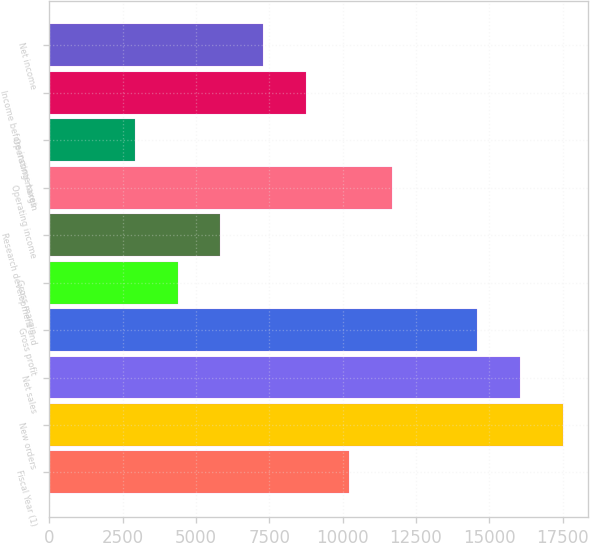Convert chart to OTSL. <chart><loc_0><loc_0><loc_500><loc_500><bar_chart><fcel>Fiscal Year (1)<fcel>New orders<fcel>Net sales<fcel>Gross profit<fcel>Gross margin<fcel>Research development and<fcel>Operating income<fcel>Operating margin<fcel>Income before income taxes<fcel>Net income<nl><fcel>10211.7<fcel>17505.5<fcel>16046.8<fcel>14588<fcel>4376.68<fcel>5835.44<fcel>11670.5<fcel>2917.92<fcel>8752.96<fcel>7294.2<nl></chart> 